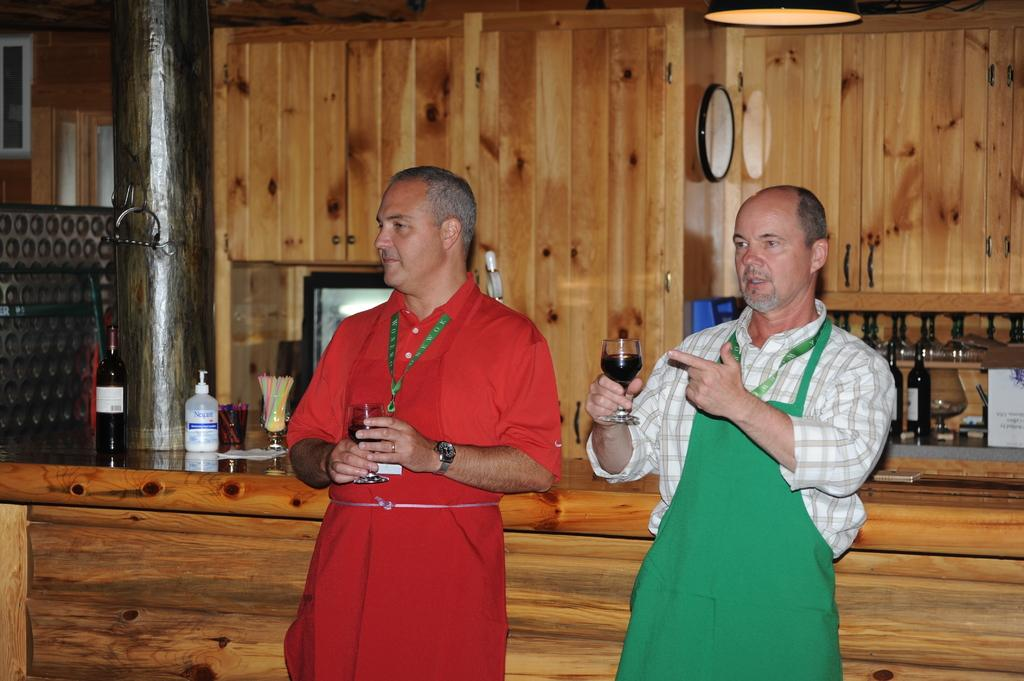How many people are in the image? There are two people in the image. What are the people holding in their hands? The people are holding glasses with drinks. What can be seen in the background of the image? There is a wooden platform, bottles, and a wooden wall in the background of the image. Can you describe the unspecified objects in the background? Unfortunately, the provided facts do not specify the nature of the unspecified objects in the background. Is there a mailbox visible in the image? No, there is no mailbox present in the image. What type of suit is the person wearing in the image? The provided facts do not mention any clothing, so we cannot determine if a suit is being worn. Is there a spade visible in the image? No, there is no spade present in the image. 